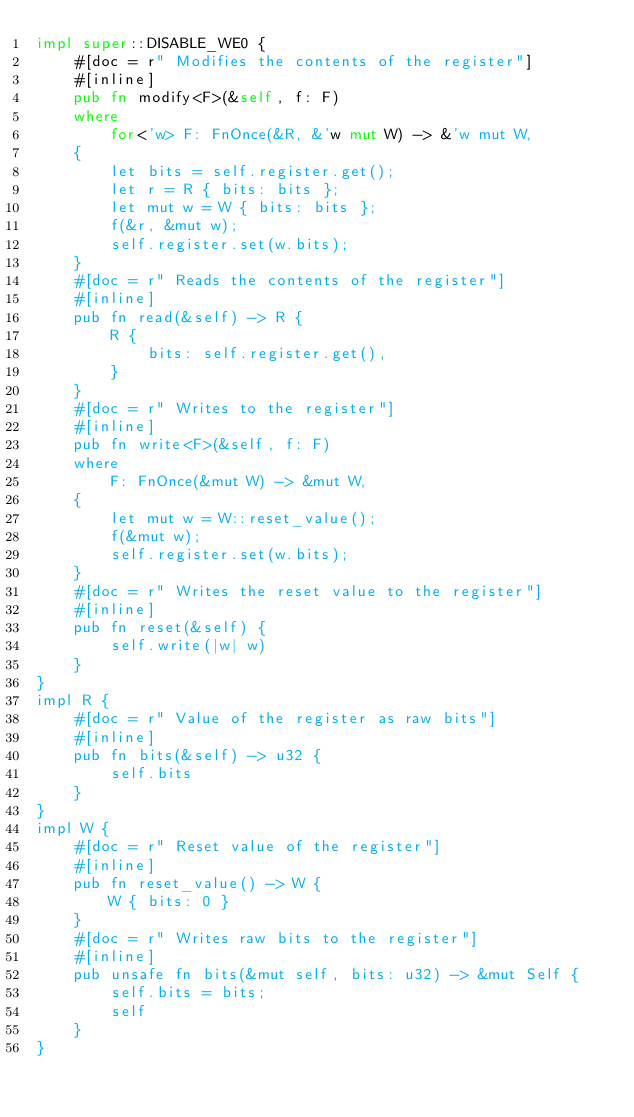<code> <loc_0><loc_0><loc_500><loc_500><_Rust_>impl super::DISABLE_WE0 {
    #[doc = r" Modifies the contents of the register"]
    #[inline]
    pub fn modify<F>(&self, f: F)
    where
        for<'w> F: FnOnce(&R, &'w mut W) -> &'w mut W,
    {
        let bits = self.register.get();
        let r = R { bits: bits };
        let mut w = W { bits: bits };
        f(&r, &mut w);
        self.register.set(w.bits);
    }
    #[doc = r" Reads the contents of the register"]
    #[inline]
    pub fn read(&self) -> R {
        R {
            bits: self.register.get(),
        }
    }
    #[doc = r" Writes to the register"]
    #[inline]
    pub fn write<F>(&self, f: F)
    where
        F: FnOnce(&mut W) -> &mut W,
    {
        let mut w = W::reset_value();
        f(&mut w);
        self.register.set(w.bits);
    }
    #[doc = r" Writes the reset value to the register"]
    #[inline]
    pub fn reset(&self) {
        self.write(|w| w)
    }
}
impl R {
    #[doc = r" Value of the register as raw bits"]
    #[inline]
    pub fn bits(&self) -> u32 {
        self.bits
    }
}
impl W {
    #[doc = r" Reset value of the register"]
    #[inline]
    pub fn reset_value() -> W {
        W { bits: 0 }
    }
    #[doc = r" Writes raw bits to the register"]
    #[inline]
    pub unsafe fn bits(&mut self, bits: u32) -> &mut Self {
        self.bits = bits;
        self
    }
}
</code> 